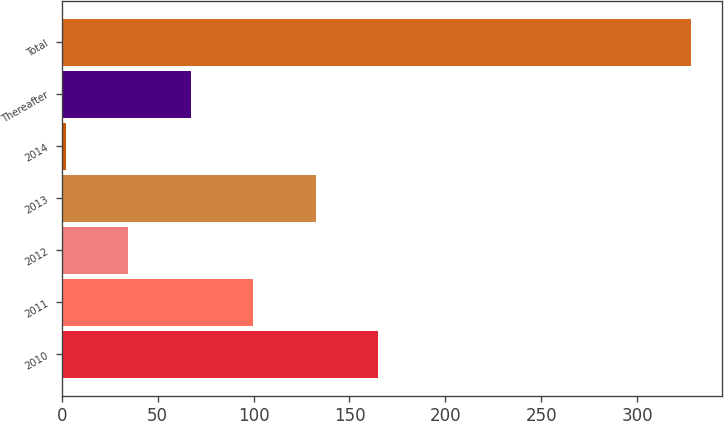Convert chart to OTSL. <chart><loc_0><loc_0><loc_500><loc_500><bar_chart><fcel>2010<fcel>2011<fcel>2012<fcel>2013<fcel>2014<fcel>Thereafter<fcel>Total<nl><fcel>165<fcel>99.8<fcel>34.6<fcel>132.4<fcel>2<fcel>67.2<fcel>328<nl></chart> 